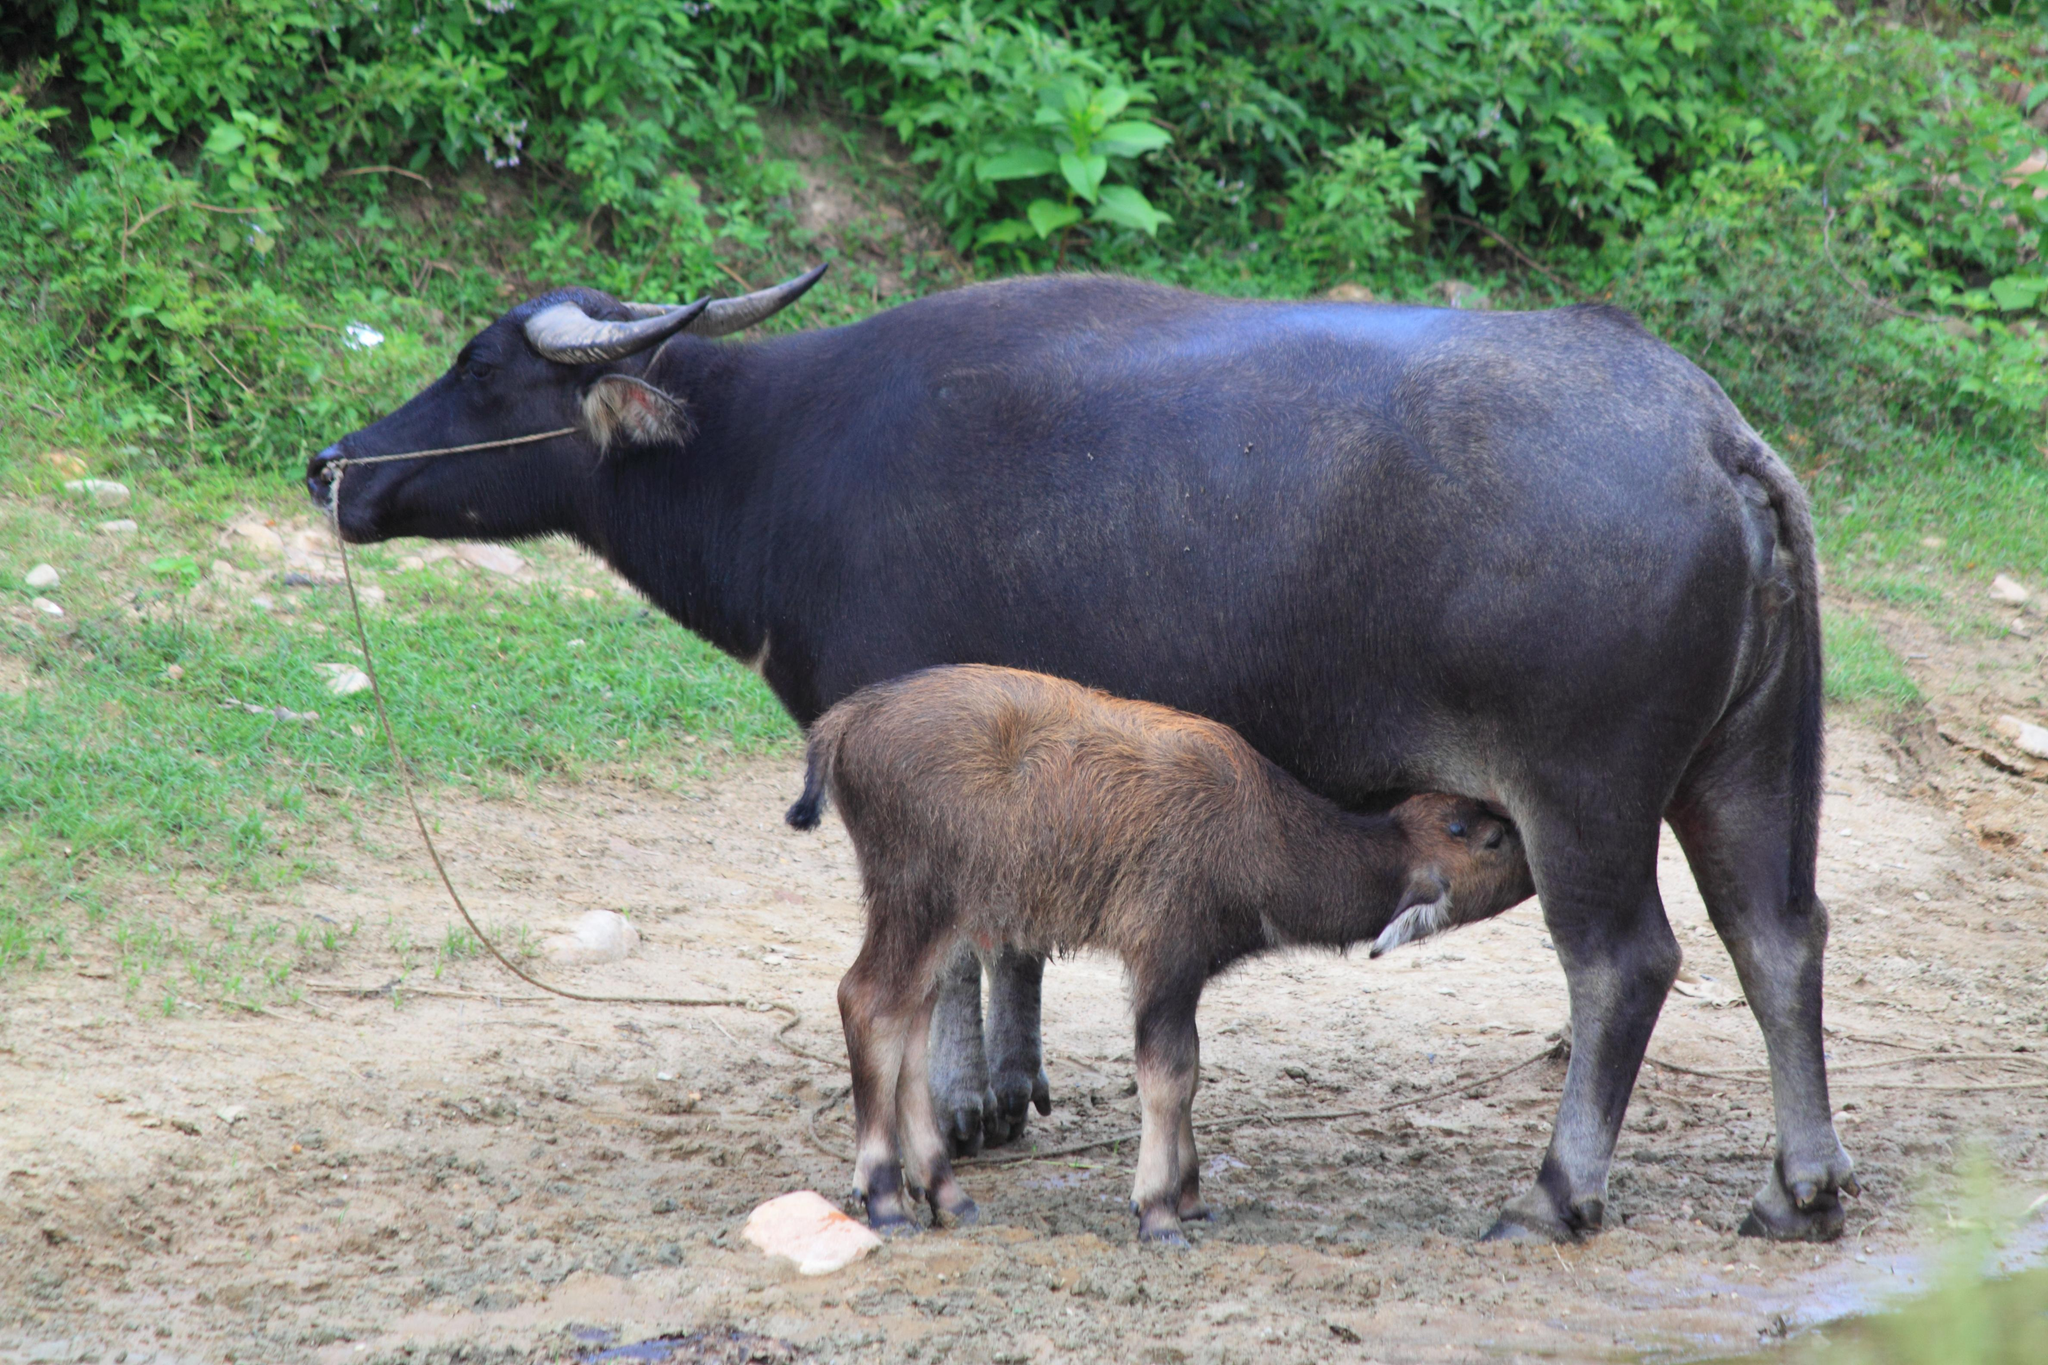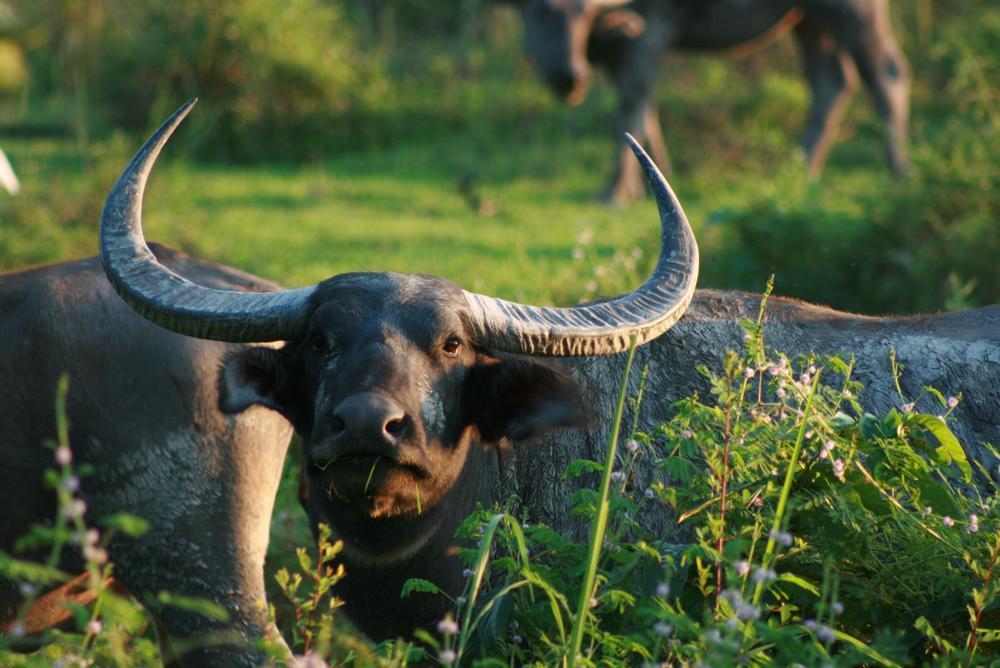The first image is the image on the left, the second image is the image on the right. Considering the images on both sides, is "Two water buffalo are present in the left image." valid? Answer yes or no. Yes. 